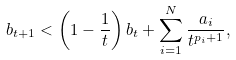Convert formula to latex. <formula><loc_0><loc_0><loc_500><loc_500>b _ { t + 1 } < \left ( 1 - \frac { 1 } { t } \right ) b _ { t } + \sum _ { i = 1 } ^ { N } \frac { a _ { i } } { t ^ { p _ { i } + 1 } } ,</formula> 